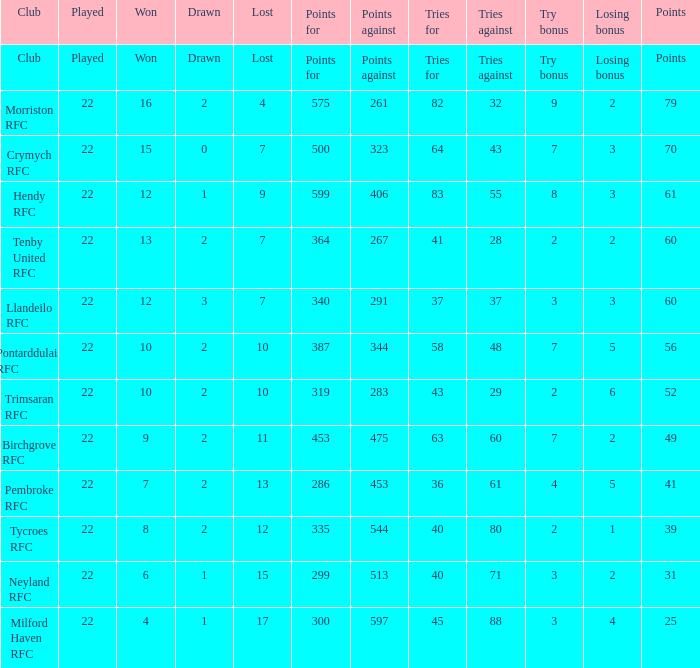When there are 43 tries for, how many points are against? 1.0. 